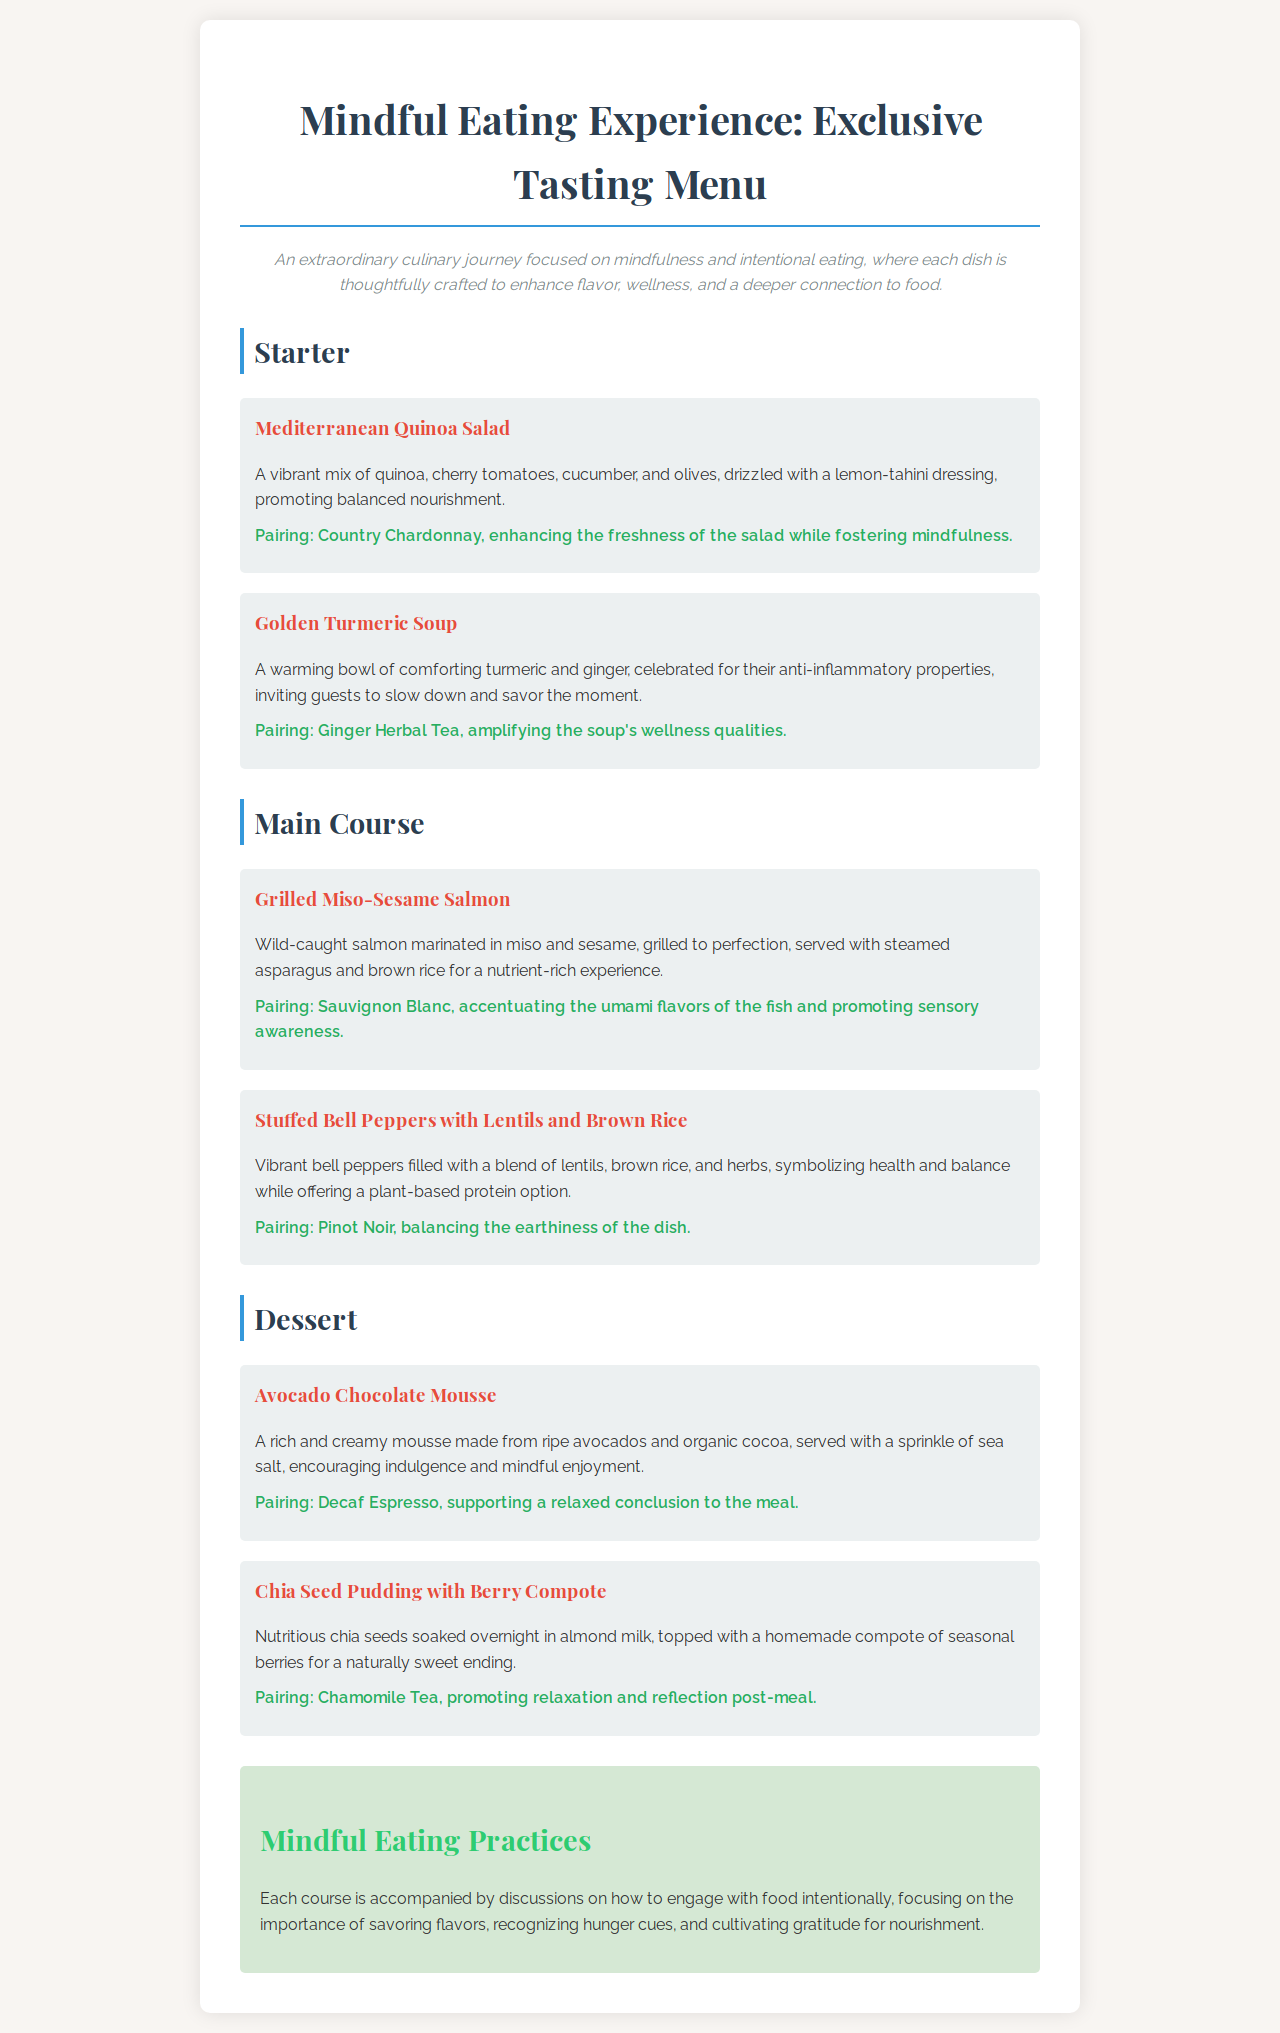What is the first dish listed in the starter section? The first dish listed is Mediterranean Quinoa Salad, found in the Starter section of the menu.
Answer: Mediterranean Quinoa Salad What pairs with the Golden Turmeric Soup? The Golden Turmeric Soup is paired with Ginger Herbal Tea, mentioned directly in the dish description.
Answer: Ginger Herbal Tea How many main course dishes are featured on the menu? There are two main course dishes listed in the document, counted from the Main Course section.
Answer: 2 What type of tea accompanies the Chia Seed Pudding with Berry Compote? The Chia Seed Pudding is paired with Chamomile Tea, as stated in the dessert pairing.
Answer: Chamomile Tea What is the theme of the Mindful Eating Experience? The theme is focused on mindfulness and intentional eating, highlighted in the description of the experience.
Answer: Mindfulness and intentional eating Which dessert encourages indulgence and mindful enjoyment? The Avocado Chocolate Mousse is specifically suggested to encourage indulgence and mindful enjoyment in the dessert section.
Answer: Avocado Chocolate Mousse What type of salmon is used in the grilled main course? The grilled main course features Wild-caught salmon as mentioned in the dish description.
Answer: Wild-caught salmon What overarching practice accompanies each course? Mindful Eating Practices are discussed with each course, focusing on intentional engagement with food.
Answer: Mindful Eating Practices 